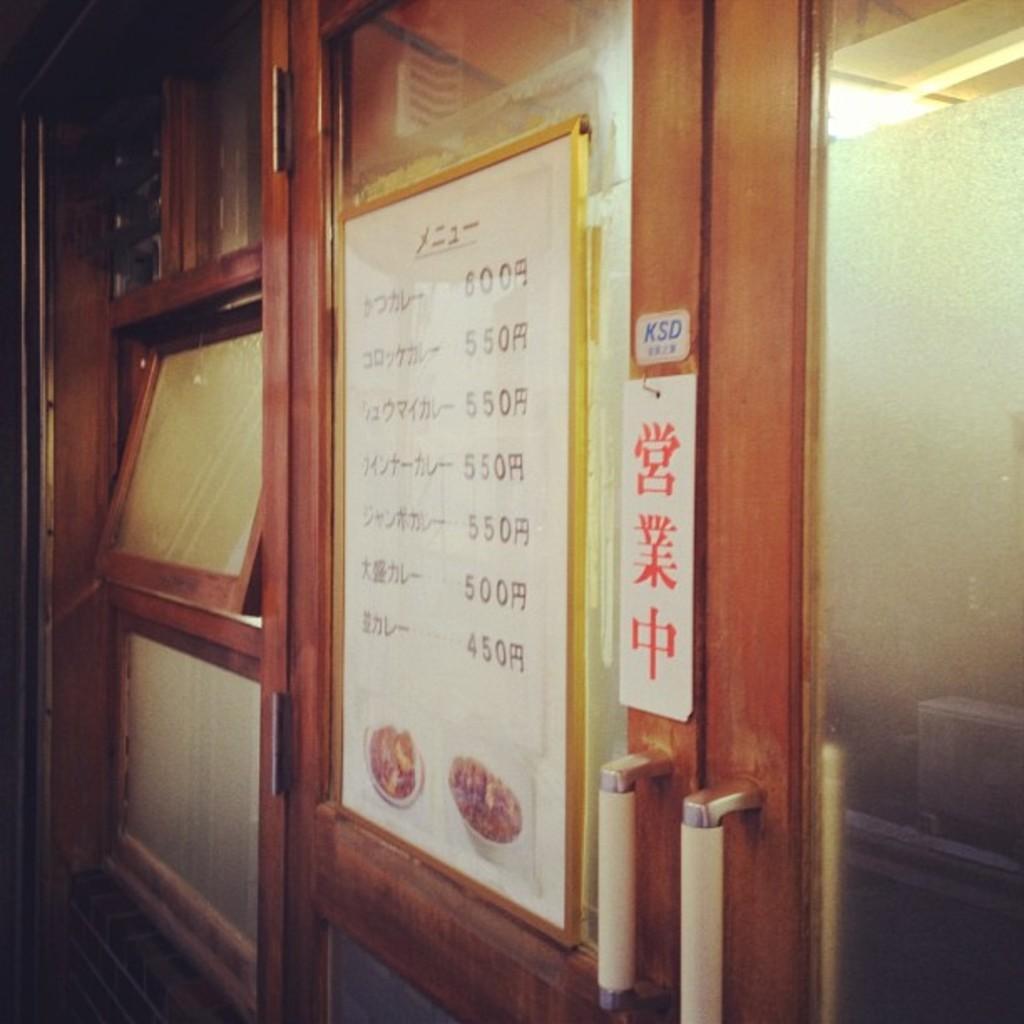Can you describe this image briefly? In this image we can see the door. We can also see the menu board with the text and also the price. On the left we can see the windows. 